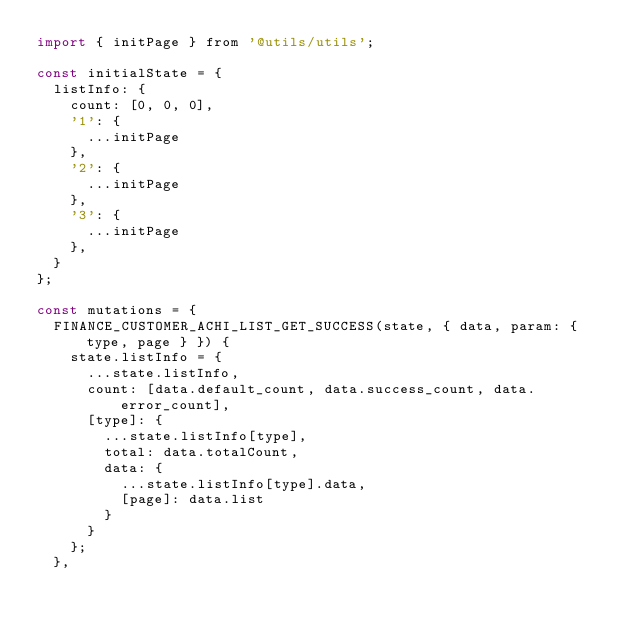<code> <loc_0><loc_0><loc_500><loc_500><_JavaScript_>import { initPage } from '@utils/utils';

const initialState = {
	listInfo: {
		count: [0, 0, 0],
		'1': {
			...initPage
		},
		'2': {
			...initPage
		},
		'3': {
			...initPage
		},
	}
};

const mutations = {
	FINANCE_CUSTOMER_ACHI_LIST_GET_SUCCESS(state, { data, param: { type, page } }) {
		state.listInfo = {
			...state.listInfo,
			count: [data.default_count, data.success_count, data.error_count],
			[type]: {
				...state.listInfo[type],
				total: data.totalCount,
				data: {
					...state.listInfo[type].data,
					[page]: data.list
				}
			}
		};
	},</code> 